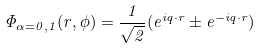<formula> <loc_0><loc_0><loc_500><loc_500>\Phi _ { \alpha = 0 , 1 } ( r , \phi ) = \frac { 1 } { \sqrt { 2 } } ( e ^ { i { q } \cdot { r } } \pm e ^ { - i { q } \cdot { r } } )</formula> 